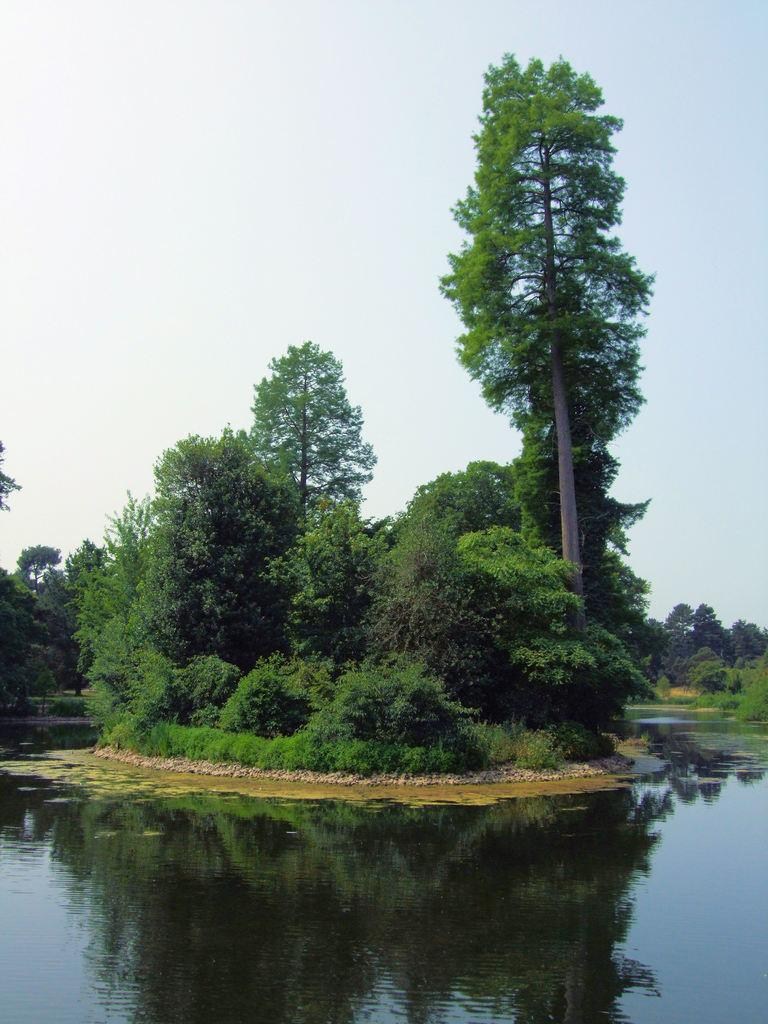What type of vegetation can be seen in the image? There are trees in the image. What is visible at the top of the image? The sky is visible at the top of the image. What can be seen at the bottom of the image? There is water visible at the bottom of the image. What is reflected on the water's surface? The reflection of the sky and trees can be seen on the water. How many parcels are floating on the water in the image? There are no parcels present in the image; it features trees, sky, and water with reflections. 